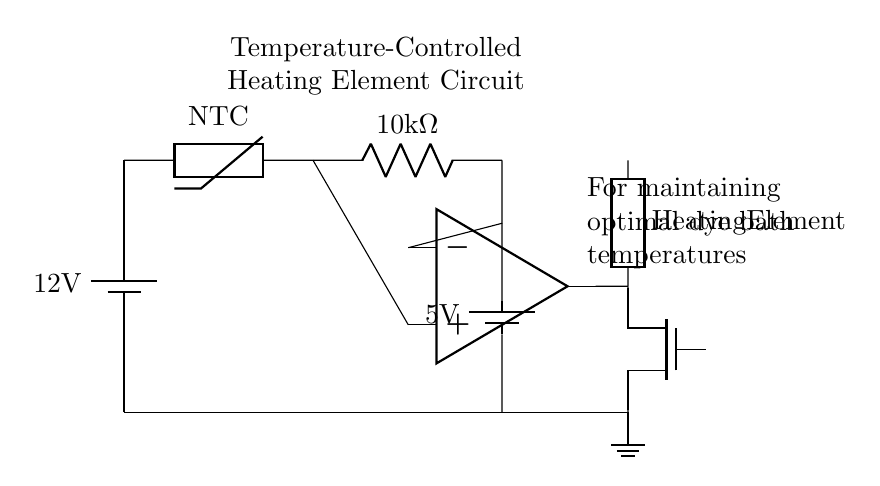What is the voltage supplied to the circuit? The circuit is powered by a 12V battery, as indicated by the label on the battery symbol.
Answer: 12V What type of thermistor is used in this circuit? The circuit diagram specifies that the component is a Negative Temperature Coefficient (NTC) thermistor. NTC thermistors decrease resistance as the temperature rises.
Answer: NTC How many heating elements are shown in the circuit? The diagram illustrates one heating element, labeled as "Heating Element." There is only one component designated for heating.
Answer: One What is the resistance value of the resistor in the circuit? The resistor in the circuit is labeled as 10kΩ, which shows the resistance value clearly next to the resistor symbol.
Answer: 10kΩ What role does the op-amp serve in this circuit? In this circuit, the operational amplifier (op-amp) compares the voltage from the thermistor to a reference voltage to control the MOSFET, thus regulating the heating element based on temperature.
Answer: Temperature control What voltage is used as the reference for the op-amp? The op-amp uses a 5V battery as its reference voltage, clearly marked below the op-amp symbol in the circuit.
Answer: 5V 